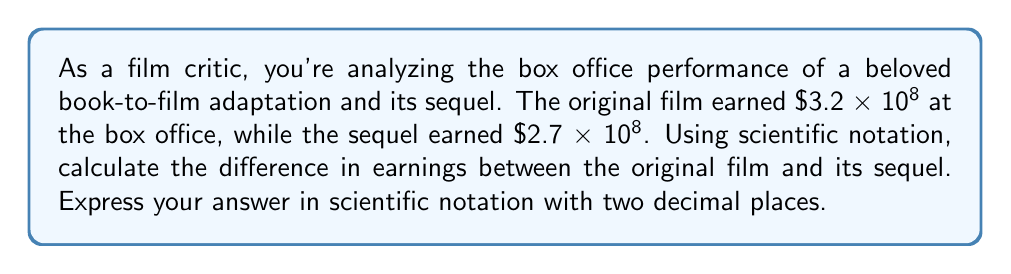Could you help me with this problem? To solve this problem, we'll follow these steps:

1) First, let's identify the given values:
   Original film earnings: $3.2 × 10^8$
   Sequel earnings: $2.7 × 10^8$

2) To find the difference, we need to subtract the sequel's earnings from the original film's earnings:

   $$(3.2 × 10^8) - (2.7 × 10^8)$$

3) When subtracting numbers in scientific notation with the same power of 10, we can subtract the coefficients and keep the power of 10 the same:

   $$(3.2 - 2.7) × 10^8$$

4) Perform the subtraction:

   $$0.5 × 10^8$$

5) This is already in scientific notation, but we need to express it with two decimal places:

   $$5.00 × 10^7$$

Note: We moved the decimal point one place to the right (5.00 instead of 0.50) and correspondingly decreased the exponent by 1 (10^7 instead of 10^8).

This final form, $5.00 × 10^7$, represents 50 million dollars, which is the difference in earnings between the original film and its sequel.
Answer: $5.00 × 10^7$ 